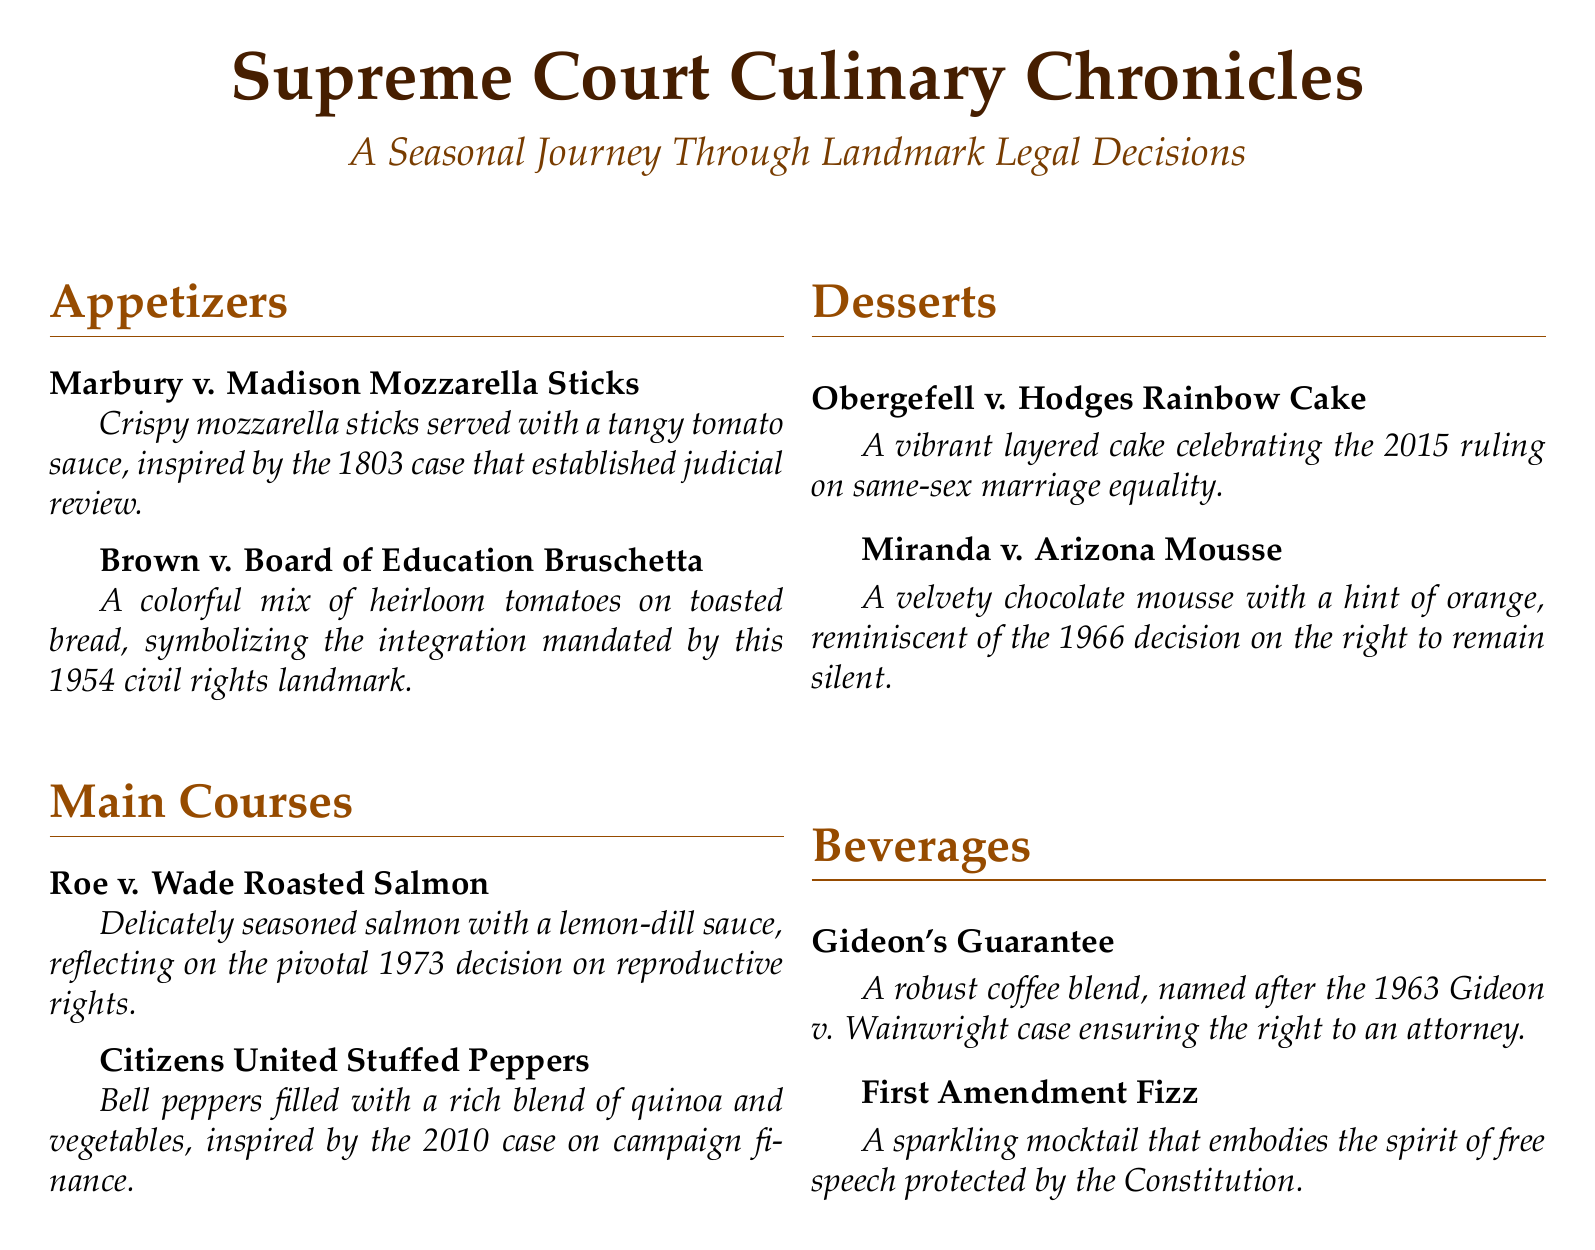What is the title of the menu? The title of the menu is prominently featured at the top of the document, stating its theme.
Answer: Supreme Court Culinary Chronicles How many appetizers are listed? The appetizers section contains two distinct items.
Answer: 2 What is the main ingredient in the Roe v. Wade Roasted Salmon? The description of the dish highlights the main ingredient being used.
Answer: Salmon In what year was the Marbury v. Madison case decided? The appetizer description references this landmark case established in 1803.
Answer: 1803 What color is the Obergefell v. Hodges Rainbow Cake? The name of the dessert indicates its vibrant and varied appearance.
Answer: Rainbow Which beverage reflects free speech? The beverages section explicitly mentions this concept in the name.
Answer: First Amendment Fizz What legal topic does the Citizens United Stuffed Peppers relate to? The name of the dish connects it to a significant case regarding a specific legal matter.
Answer: Campaign finance What year was Obergefell v. Hodges decided? The dessert description indicates the year of the landmark ruling.
Answer: 2015 How many main course options are provided? The main courses section lists two different dishes available.
Answer: 2 